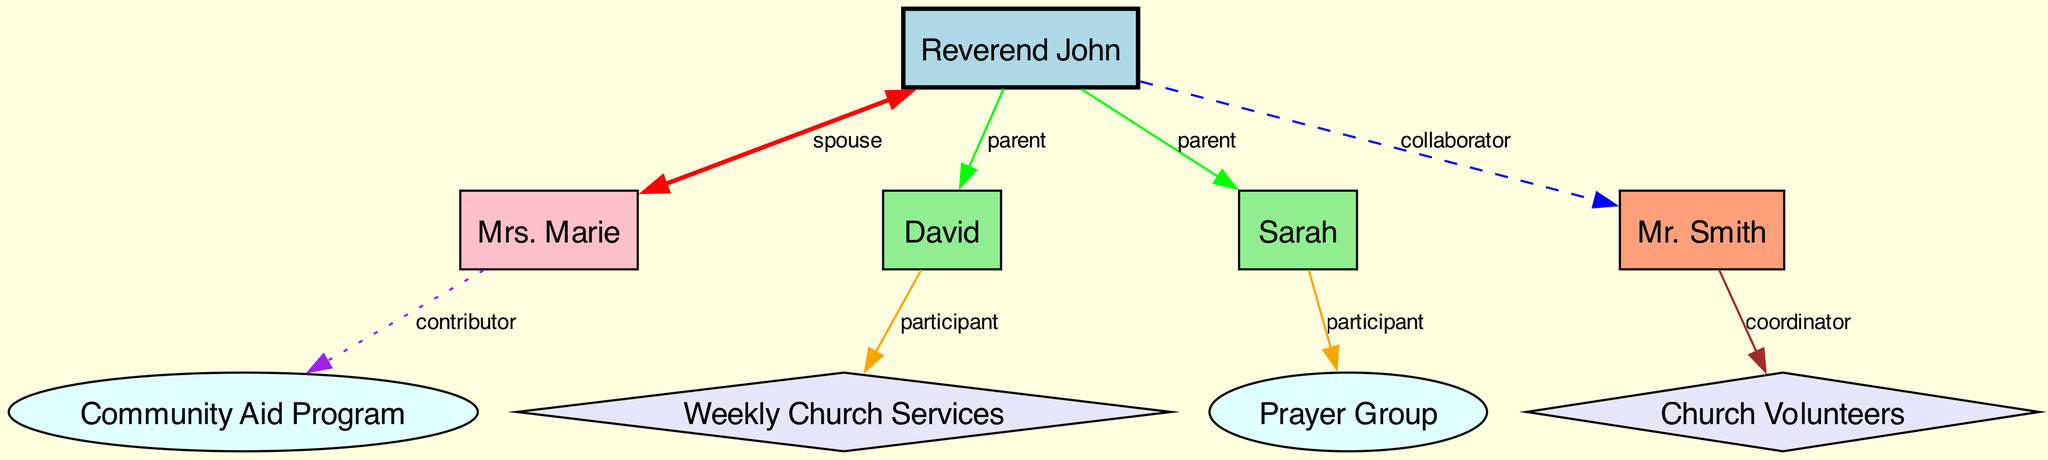What is the relationship of Mr. Smith to Reverend John? The diagram indicates that Mr. Smith has a "collaborator" relationship with Reverend John, as represented by a dashed line connecting the two.
Answer: collaborator How many children does Reverend John have? The diagram shows two direct connections (edges) between Reverend John and his children, David and Sarah, indicating he has two children.
Answer: 2 What type of edge connects Mrs. Marie to the Community Aid Program? The edge connecting Mrs. Marie to the Community Aid Program is labeled as "contributor," represented by a dotted line in the diagram.
Answer: contributor Which family member participates in the Prayer Group? The diagram indicates that Sarah is the participant connected to the Prayer Group, as denoted by the orange edge linking her to it.
Answer: Sarah How many church involvement nodes are illustrated in the diagram? The diagram depicts three nodes representing church involvement: Weekly Church Services, Prayer Group, and Church Volunteers. By counting these nodes, we find there are three.
Answer: 3 Which node has a spouse relationship with Reverend John? The diagram specifies that Mrs. Marie is linked to Reverend John via "spouse," indicated by a red edge that is two-way, showing mutual engagement.
Answer: Mrs. Marie Who coordinates the church volunteers? The diagram clearly shows that Mr. Smith is designated as the coordinator for the Volunteers, reflected by a brown edge emanating from him to the Volunteers node.
Answer: Mr. Smith What color represents the Family Head in the diagram? The Family Head, represented by Reverend John, is shown in light blue, which is the specified color for this type of node in the diagram.
Answer: light blue Which support offering does Mrs. Marie contribute to? The diagram shows an edge from Mrs. Marie to the Community Aid Program, indicating it is the support offering she contributes to.
Answer: Community Aid Program 